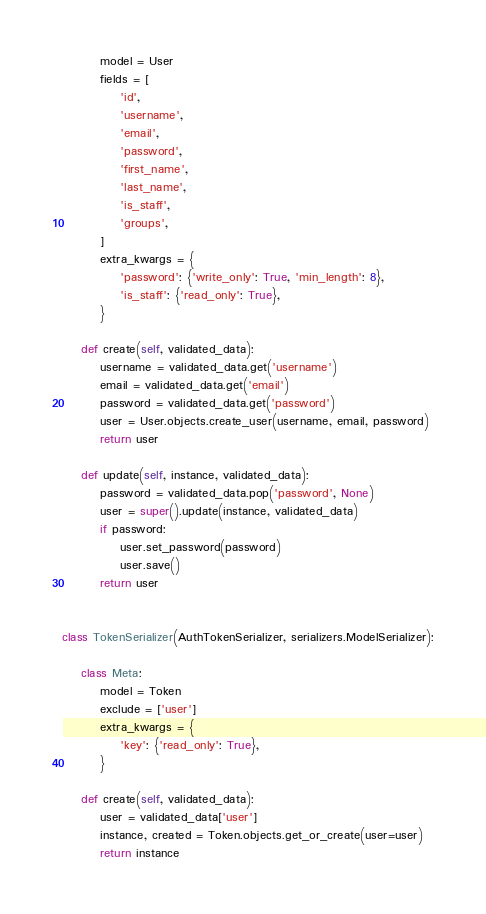Convert code to text. <code><loc_0><loc_0><loc_500><loc_500><_Python_>        model = User
        fields = [
            'id',
            'username',
            'email',
            'password',
            'first_name',
            'last_name',
            'is_staff',
            'groups',
        ]
        extra_kwargs = {
            'password': {'write_only': True, 'min_length': 8},
            'is_staff': {'read_only': True},
        }

    def create(self, validated_data):
        username = validated_data.get('username')
        email = validated_data.get('email')
        password = validated_data.get('password')
        user = User.objects.create_user(username, email, password)
        return user

    def update(self, instance, validated_data):
        password = validated_data.pop('password', None)
        user = super().update(instance, validated_data)
        if password:
            user.set_password(password)
            user.save()
        return user


class TokenSerializer(AuthTokenSerializer, serializers.ModelSerializer):

    class Meta:
        model = Token
        exclude = ['user']
        extra_kwargs = {
            'key': {'read_only': True},
        }

    def create(self, validated_data):
        user = validated_data['user']
        instance, created = Token.objects.get_or_create(user=user)
        return instance
</code> 